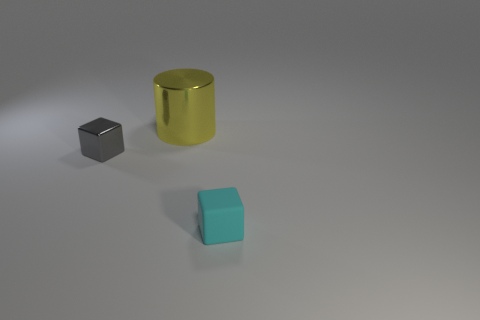What is the color of the other cube that is the same size as the cyan matte cube?
Give a very brief answer. Gray. Is the material of the yellow cylinder the same as the gray thing?
Keep it short and to the point. Yes. What is the material of the object that is behind the tiny cube on the left side of the tiny cyan block?
Your answer should be very brief. Metal. Is the number of metallic cylinders that are to the right of the gray object greater than the number of small yellow balls?
Give a very brief answer. Yes. What number of other things are there of the same size as the cyan cube?
Provide a succinct answer. 1. What color is the small thing that is behind the cyan rubber thing on the right side of the shiny thing that is behind the small gray metallic object?
Make the answer very short. Gray. How many big yellow cylinders are behind the cube that is behind the cube that is in front of the metallic cube?
Ensure brevity in your answer.  1. Is there any other thing that is the same color as the small rubber cube?
Provide a short and direct response. No. There is a cube on the right side of the gray object; is its size the same as the yellow metal object?
Ensure brevity in your answer.  No. There is a tiny cube that is behind the rubber cube; what number of yellow objects are on the left side of it?
Provide a short and direct response. 0. 